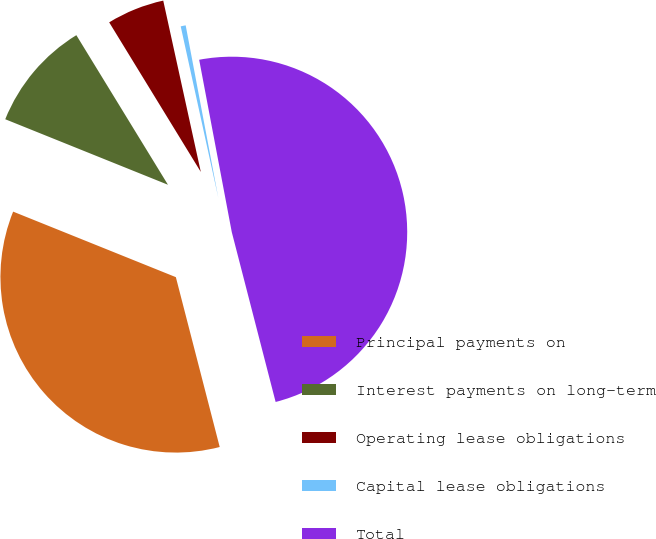Convert chart to OTSL. <chart><loc_0><loc_0><loc_500><loc_500><pie_chart><fcel>Principal payments on<fcel>Interest payments on long-term<fcel>Operating lease obligations<fcel>Capital lease obligations<fcel>Total<nl><fcel>35.11%<fcel>10.16%<fcel>5.31%<fcel>0.46%<fcel>48.95%<nl></chart> 